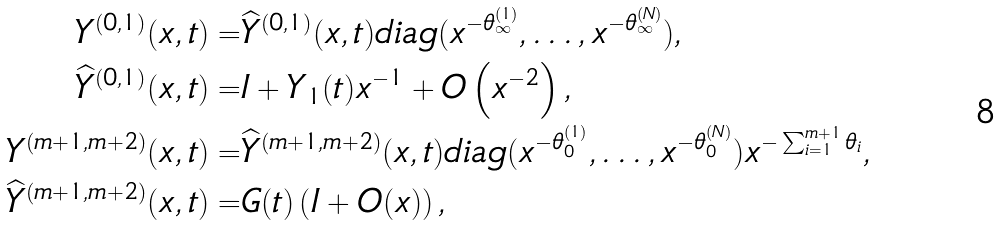Convert formula to latex. <formula><loc_0><loc_0><loc_500><loc_500>Y ^ { ( 0 , 1 ) } ( x , t ) = & \widehat { Y } ^ { ( 0 , 1 ) } ( x , t ) d i a g ( x ^ { - \theta _ { \infty } ^ { ( 1 ) } } , \dots , x ^ { - \theta _ { \infty } ^ { ( N ) } } ) , \quad \\ \widehat { Y } ^ { ( 0 , 1 ) } ( x , t ) = & I + Y _ { 1 } ( t ) x ^ { - 1 } + O \left ( x ^ { - 2 } \right ) , \\ Y ^ { ( m + 1 , m + 2 ) } ( x , t ) = & \widehat { Y } ^ { ( m + 1 , m + 2 ) } ( x , t ) d i a g ( x ^ { - \theta _ { 0 } ^ { ( 1 ) } } , \dots , x ^ { - \theta _ { 0 } ^ { ( N ) } } ) x ^ { - \sum _ { i = 1 } ^ { m + 1 } \theta _ { i } } , \\ \widehat { Y } ^ { ( m + 1 , m + 2 ) } ( x , t ) = & G ( t ) \left ( I + O ( x ) \right ) ,</formula> 